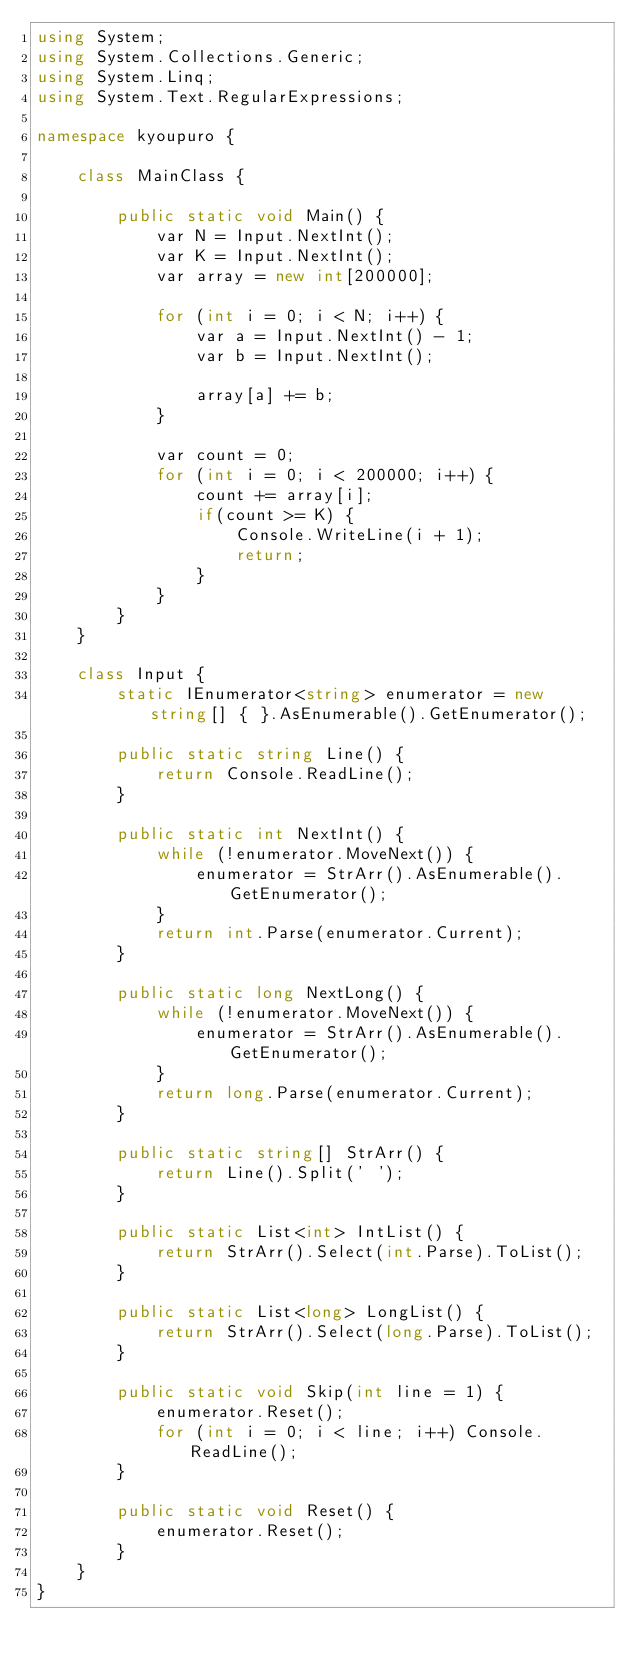<code> <loc_0><loc_0><loc_500><loc_500><_C#_>using System;
using System.Collections.Generic;
using System.Linq;
using System.Text.RegularExpressions;

namespace kyoupuro {

    class MainClass {

        public static void Main() {
            var N = Input.NextInt();
            var K = Input.NextInt();
            var array = new int[200000];

            for (int i = 0; i < N; i++) {
                var a = Input.NextInt() - 1;
                var b = Input.NextInt();

                array[a] += b;
            }

            var count = 0;
            for (int i = 0; i < 200000; i++) {
                count += array[i];
                if(count >= K) {
                    Console.WriteLine(i + 1);
                    return;
                }
            }
        }
    }

    class Input {
        static IEnumerator<string> enumerator = new string[] { }.AsEnumerable().GetEnumerator();

        public static string Line() {
            return Console.ReadLine();
        }

        public static int NextInt() {
            while (!enumerator.MoveNext()) {
                enumerator = StrArr().AsEnumerable().GetEnumerator();
            }
            return int.Parse(enumerator.Current);
        }

        public static long NextLong() {
            while (!enumerator.MoveNext()) {
                enumerator = StrArr().AsEnumerable().GetEnumerator();
            }
            return long.Parse(enumerator.Current);
        }

        public static string[] StrArr() {
            return Line().Split(' ');
        }

        public static List<int> IntList() {
            return StrArr().Select(int.Parse).ToList();
        }

        public static List<long> LongList() {
            return StrArr().Select(long.Parse).ToList();
        }

        public static void Skip(int line = 1) {
            enumerator.Reset();
            for (int i = 0; i < line; i++) Console.ReadLine();
        }

        public static void Reset() {
            enumerator.Reset();
        }
    }
}</code> 